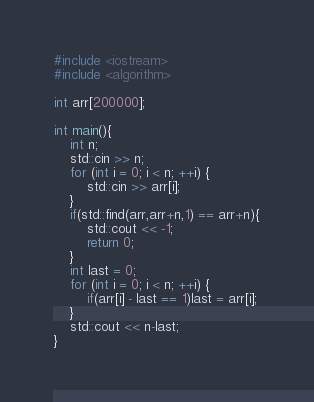Convert code to text. <code><loc_0><loc_0><loc_500><loc_500><_C++_>#include <iostream>
#include <algorithm>

int arr[200000];

int main(){
    int n;
    std::cin >> n;
    for (int i = 0; i < n; ++i) {
        std::cin >> arr[i];
    }
    if(std::find(arr,arr+n,1) == arr+n){
        std::cout << -1;
        return 0;
    }
    int last = 0;
    for (int i = 0; i < n; ++i) {
        if(arr[i] - last == 1)last = arr[i];
    }
    std::cout << n-last;
}</code> 